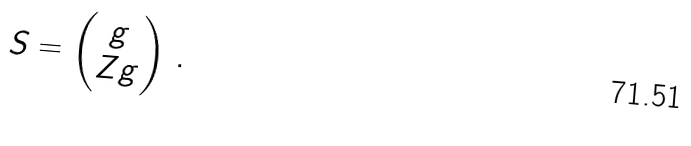<formula> <loc_0><loc_0><loc_500><loc_500>S = \begin{pmatrix} g \\ Z g \end{pmatrix} \, .</formula> 